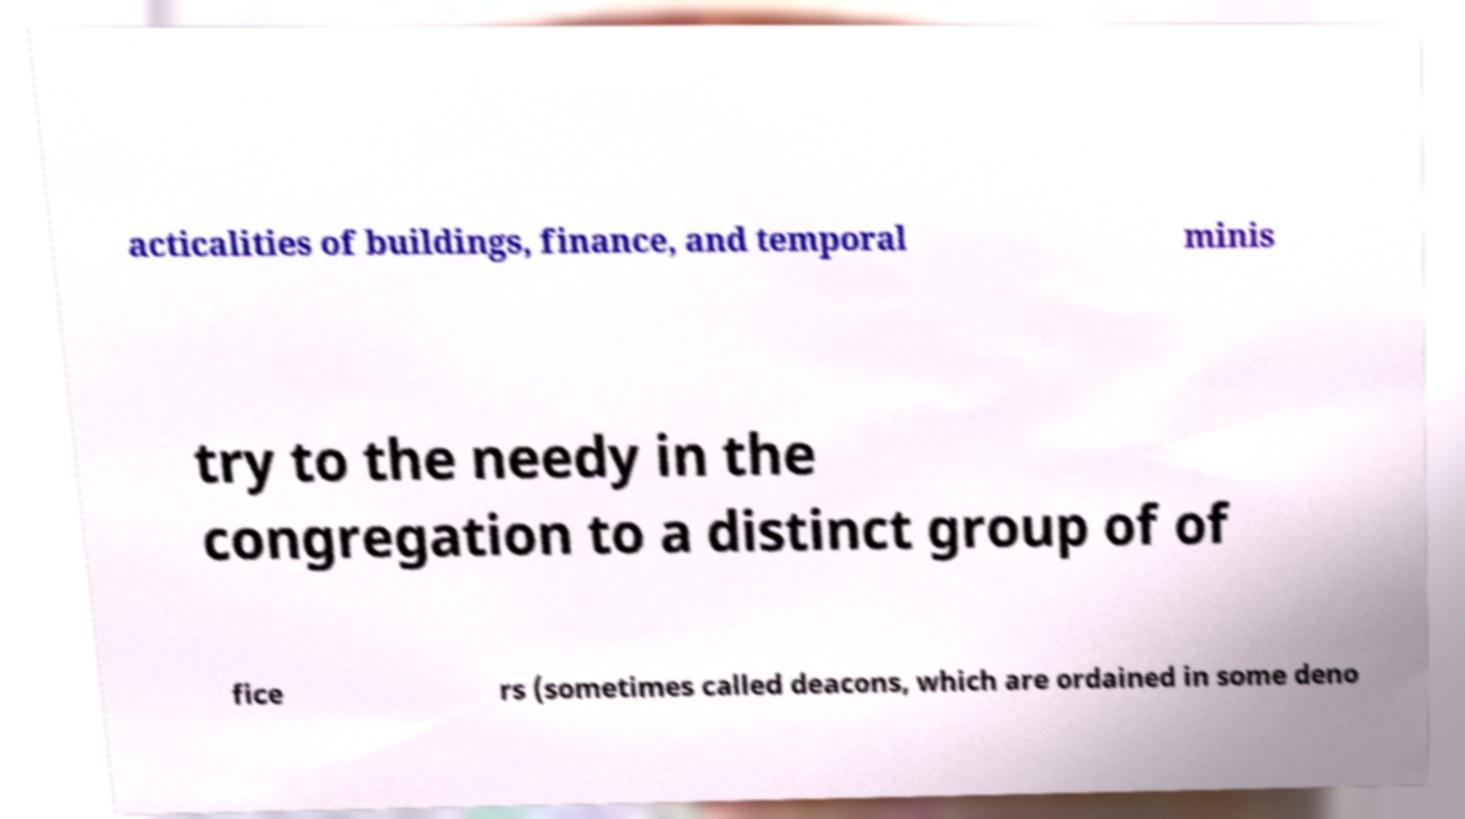There's text embedded in this image that I need extracted. Can you transcribe it verbatim? acticalities of buildings, finance, and temporal minis try to the needy in the congregation to a distinct group of of fice rs (sometimes called deacons, which are ordained in some deno 